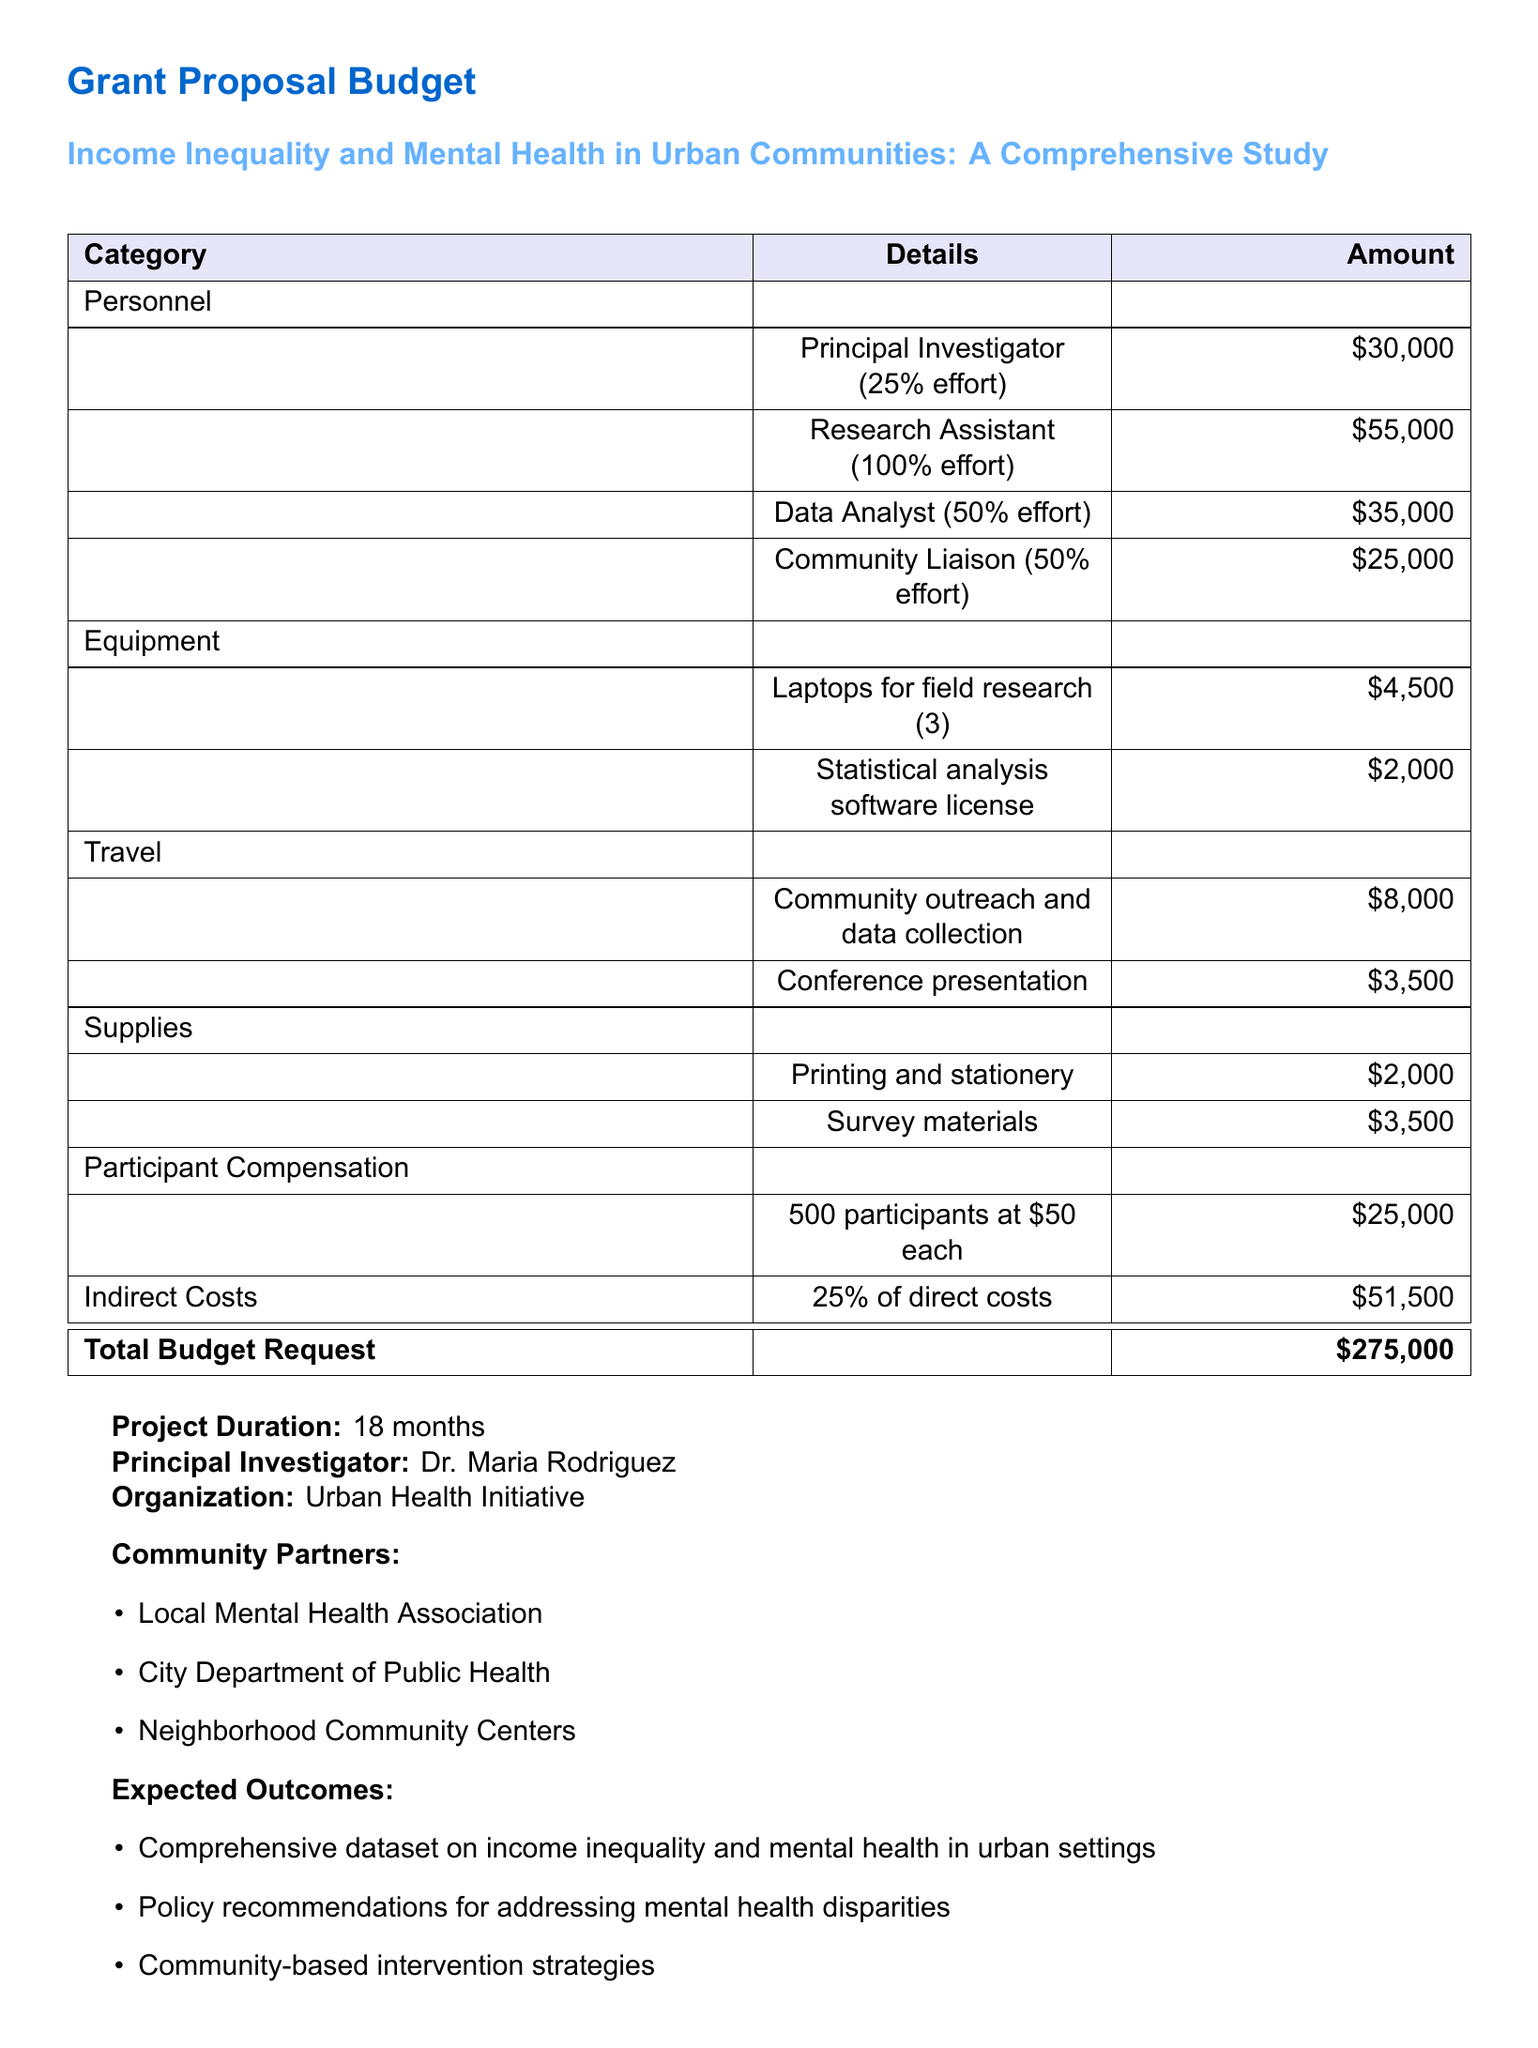What is the total budget request? The total budget request is found at the bottom of the budget table, which summarizes all expenses.
Answer: $275,000 Who is the principal investigator? The principal investigator's name can be found in the section detailing the project leadership.
Answer: Dr. Maria Rodriguez What percentage of effort is allocated to the research assistant? The effort percentage for the research assistant is listed in the personnel section of the budget.
Answer: 100% effort How much is allocated for community outreach and data collection travel? The amount allocated for travel related to community outreach is specified in the travel section.
Answer: $8,000 What are the expected outcomes of the project? The expected outcomes are described in a bulleted list towards the end of the document.
Answer: Comprehensive dataset on income inequality and mental health in urban settings How much participant compensation is included in the budget? The participant compensation total is detailed under the participant compensation category.
Answer: $25,000 What is the duration of the project? The duration of the project is mentioned below the budget table.
Answer: 18 months Which organization is leading the project? The leading organization can be found in the section identifying project details.
Answer: Urban Health Initiative What is the amount allocated for statistical analysis software? The amount for the software license is listed within the equipment section of the budget.
Answer: $2,000 What is the indirect cost percentage applied to direct costs? The indirect cost percentage is stated next to the indirect costs in the budget summary.
Answer: 25% 